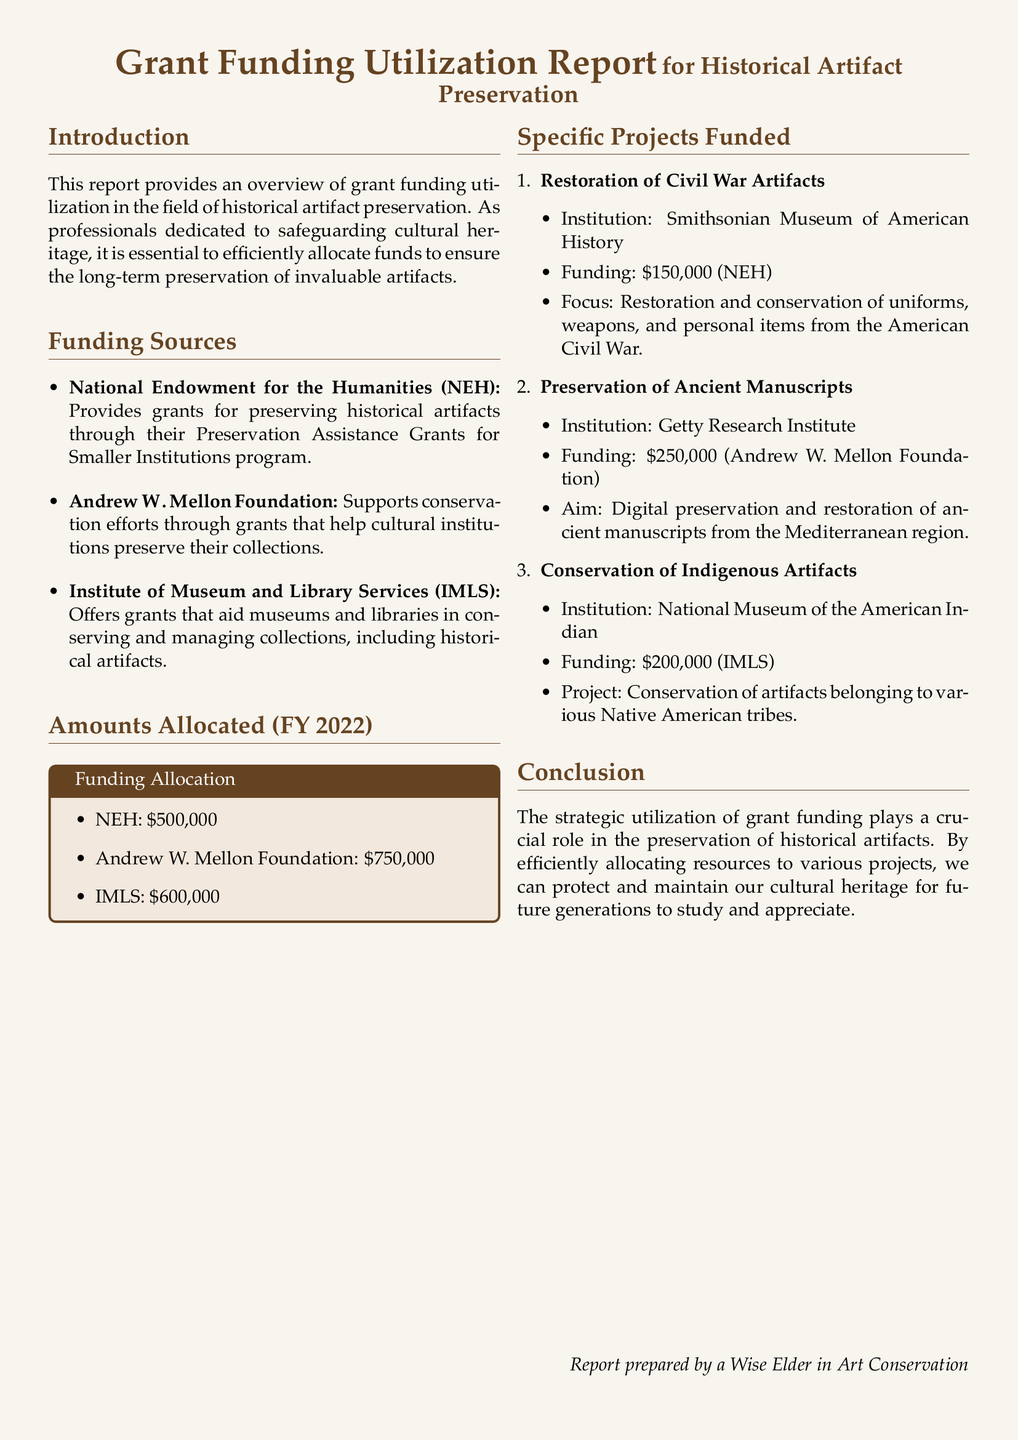What are the funding sources listed in the report? The report provides three funding sources: the National Endowment for the Humanities, Andrew W. Mellon Foundation, and Institute of Museum and Library Services.
Answer: National Endowment for the Humanities, Andrew W. Mellon Foundation, Institute of Museum and Library Services How much funding did the Andrew W. Mellon Foundation provide? The report specifies the amount allocated from the Andrew W. Mellon Foundation as part of the FY 2022 funding.
Answer: $750,000 What is the total amount allocated from all funding sources? The total funding is the sum of each allocation: $500,000 (NEH) + $750,000 (Mellon) + $600,000 (IMLS) = $1,850,000.
Answer: $1,850,000 Which institution received funding for the restoration of Civil War artifacts? The report specifies that the Smithsonian Museum of American History received funding for this project.
Answer: Smithsonian Museum of American History What was the aim of the project funded by the Andrew W. Mellon Foundation? The specifics of the project funded by the Mellon Foundation are described in the document, focusing on digital preservation.
Answer: Digital preservation and restoration of ancient manuscripts How much funding was allocated for the conservation of Indigenous artifacts? The document explicitly states the amount funded for this project within the specific projects funded section.
Answer: $200,000 Which project received the highest amount of funding? The report lists various projects funded and their respective amounts; the project with the highest amount is identified by comparing the figures.
Answer: Preservation of Ancient Manuscripts What type of document is this report classified as? The format and content described in the introduction indicate its classification.
Answer: Grant Funding Utilization Report 